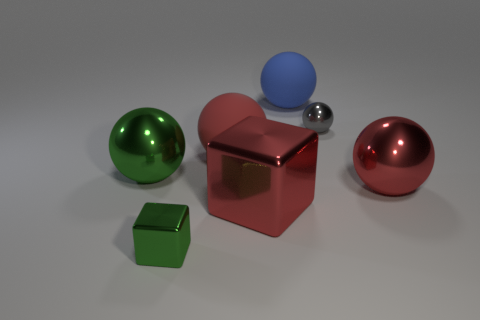Subtract all gray balls. How many balls are left? 4 Subtract all red spheres. How many spheres are left? 3 Subtract all spheres. How many objects are left? 2 Subtract all gray cubes. How many purple spheres are left? 0 Add 2 tiny gray matte objects. How many objects exist? 9 Subtract 2 cubes. How many cubes are left? 0 Subtract all gray cubes. Subtract all red cylinders. How many cubes are left? 2 Subtract all matte spheres. Subtract all green metallic things. How many objects are left? 3 Add 1 red metal objects. How many red metal objects are left? 3 Add 4 red rubber objects. How many red rubber objects exist? 5 